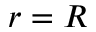Convert formula to latex. <formula><loc_0><loc_0><loc_500><loc_500>r = R</formula> 